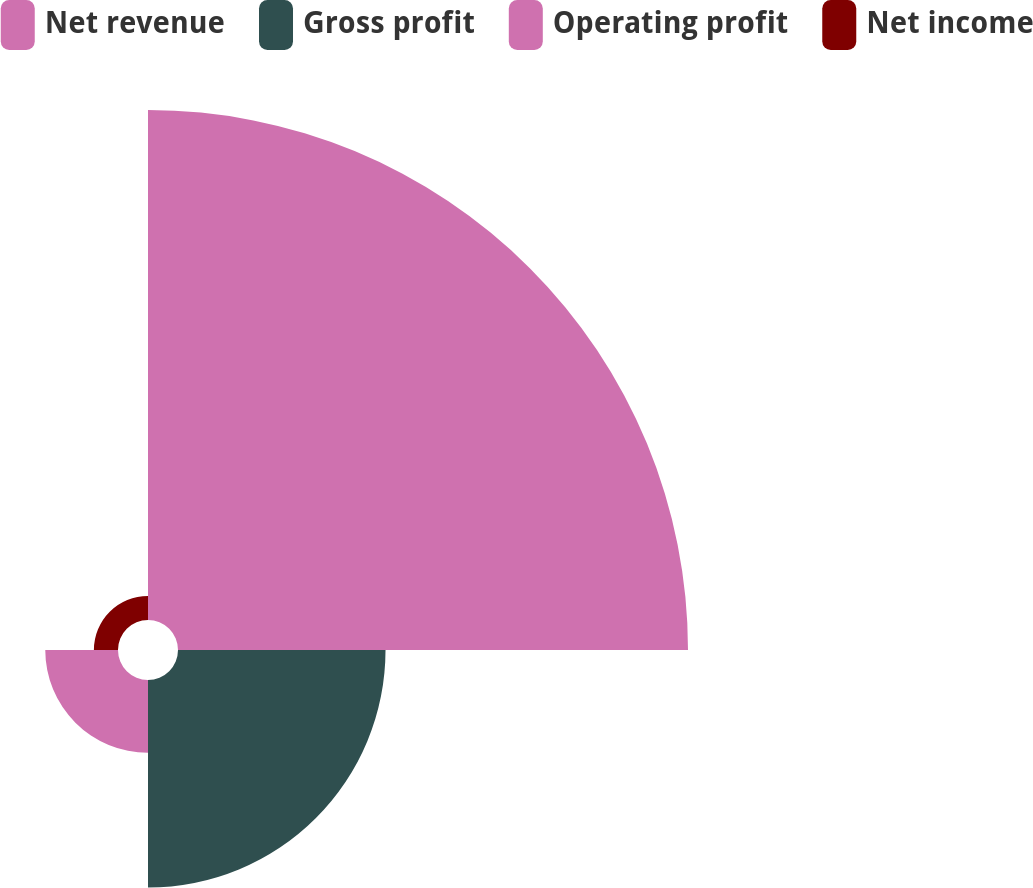Convert chart. <chart><loc_0><loc_0><loc_500><loc_500><pie_chart><fcel>Net revenue<fcel>Gross profit<fcel>Operating profit<fcel>Net income<nl><fcel>62.62%<fcel>25.48%<fcel>8.93%<fcel>2.96%<nl></chart> 